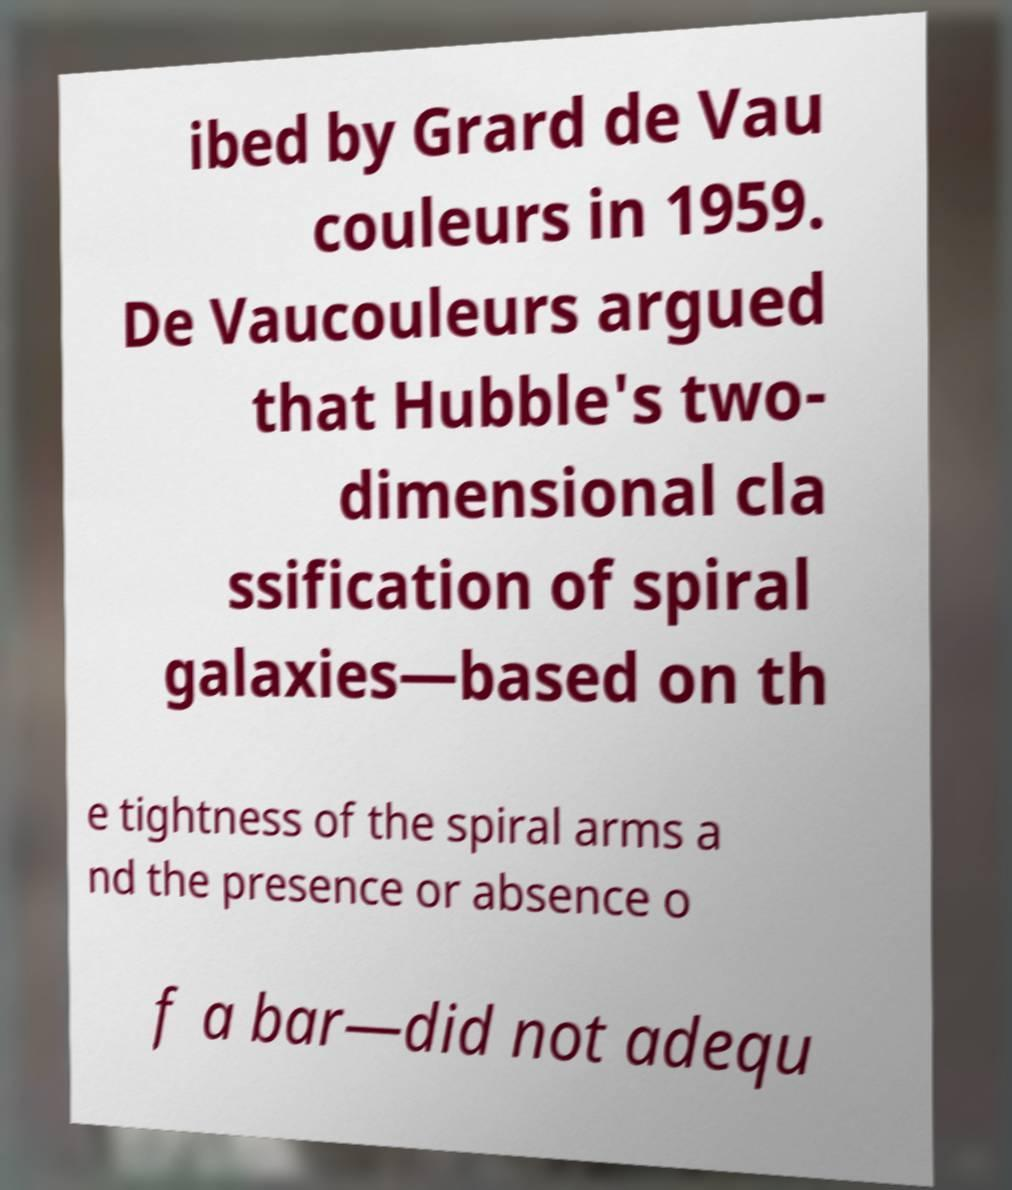Can you accurately transcribe the text from the provided image for me? ibed by Grard de Vau couleurs in 1959. De Vaucouleurs argued that Hubble's two- dimensional cla ssification of spiral galaxies—based on th e tightness of the spiral arms a nd the presence or absence o f a bar—did not adequ 